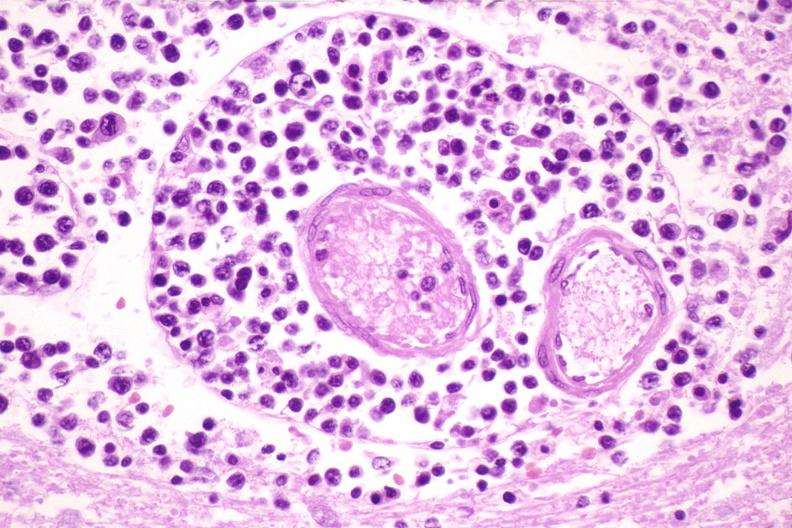s esophagus present?
Answer the question using a single word or phrase. No 